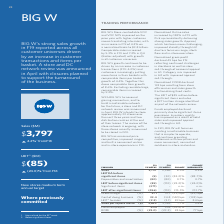According to Woolworths Limited's financial document, What is the focus of BIG W in F20? Based on the financial document, the answer is In F20, BIG W will focus on creating a sustainable business that is simpler to operate, and continue providing customers with low prices and more convenient, connected solutions in‐store and online.. Also, What is the gross margin in F19? According to the financial document, 31.1 (percentage). The relevant text states: "items (456) (110) 315.5% 313.7% Gross margin (%) 31.1 31.7 (59) bps (49) bps Cost of doing business (%) 33.4 34.8 (142) bps (132) bps LBIT 2 to sales (%)..." Also, Why did the funds employed declined? Funds employed declined primarily due to significant items provisions.. The document states: "Funds employed declined primarily due to significant items provisions. Inventory quality has improved as a result of solid sales and improved apparel ..." Also, can you calculate: What is the nominal difference between the sales in F19 and F18? Based on the calculation: 3,797 - 3,566 , the result is 231 (in millions). This is based on the information: "Sales 3,797 3,566 6.5% 4.2% LBITDA before significant items (5) (30) (82.2)% (88.7)% Depreciation and amortisation (8 Sales 3,797 3,566 6.5% 4.2% LBITDA before significant items (5) (30) (82.2)% (88.7..." The key data points involved are: 3,566, 3,797. Also, can you calculate: What is the average cost of doing business (%) for both F19 and F18? To answer this question, I need to perform calculations using the financial data. The calculation is: (33.4 + 34.8)/2 , which equals 34.1 (percentage). This is based on the information: "(59) bps (49) bps Cost of doing business (%) 33.4 34.8 (142) bps (132) bps LBIT 2 to sales (%) (2.3) (3.1) 83 bps 84 bps Sales per square metre ($) 3,629 31.7 (59) bps (49) bps Cost of doing business ..." The key data points involved are: 33.4, 34.8. Also, can you calculate: What is the nominal difference between sales per square metre for F19 and F18? Based on the calculation: 3,629 - 3,369 , the result is 260 (in millions). This is based on the information: "3) (3.1) 83 bps 84 bps Sales per square metre ($) 3,629 3,369 7.7% 5.4% Funds employed 204 502 (59.4)% ROFE (%) (23.0) (23.3) 24 bps 77 bps 1) 83 bps 84 bps Sales per square metre ($) 3,629 3,369 7.7%..." The key data points involved are: 3,369, 3,629. 